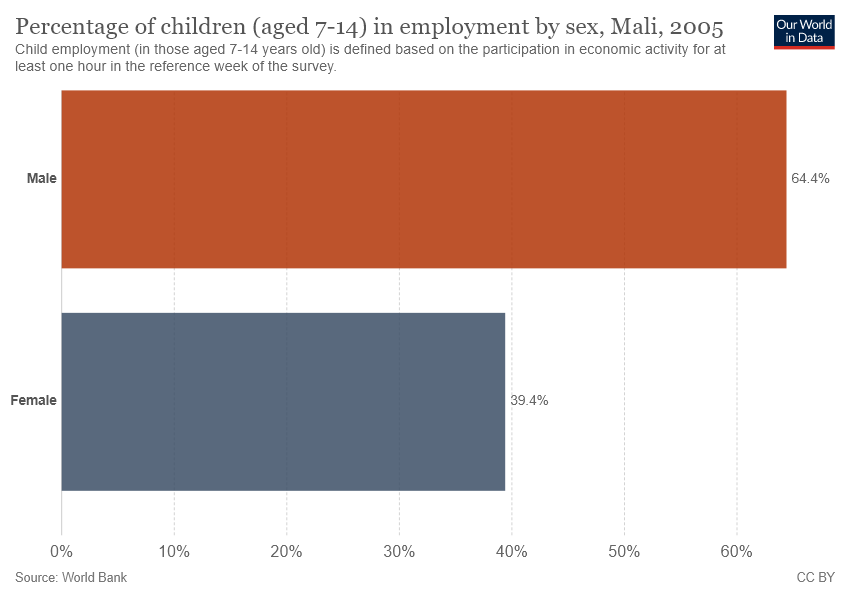Indicate a few pertinent items in this graphic. The category of female is shown in the grey bar. The Male data is higher than the Female data by 0.63. 